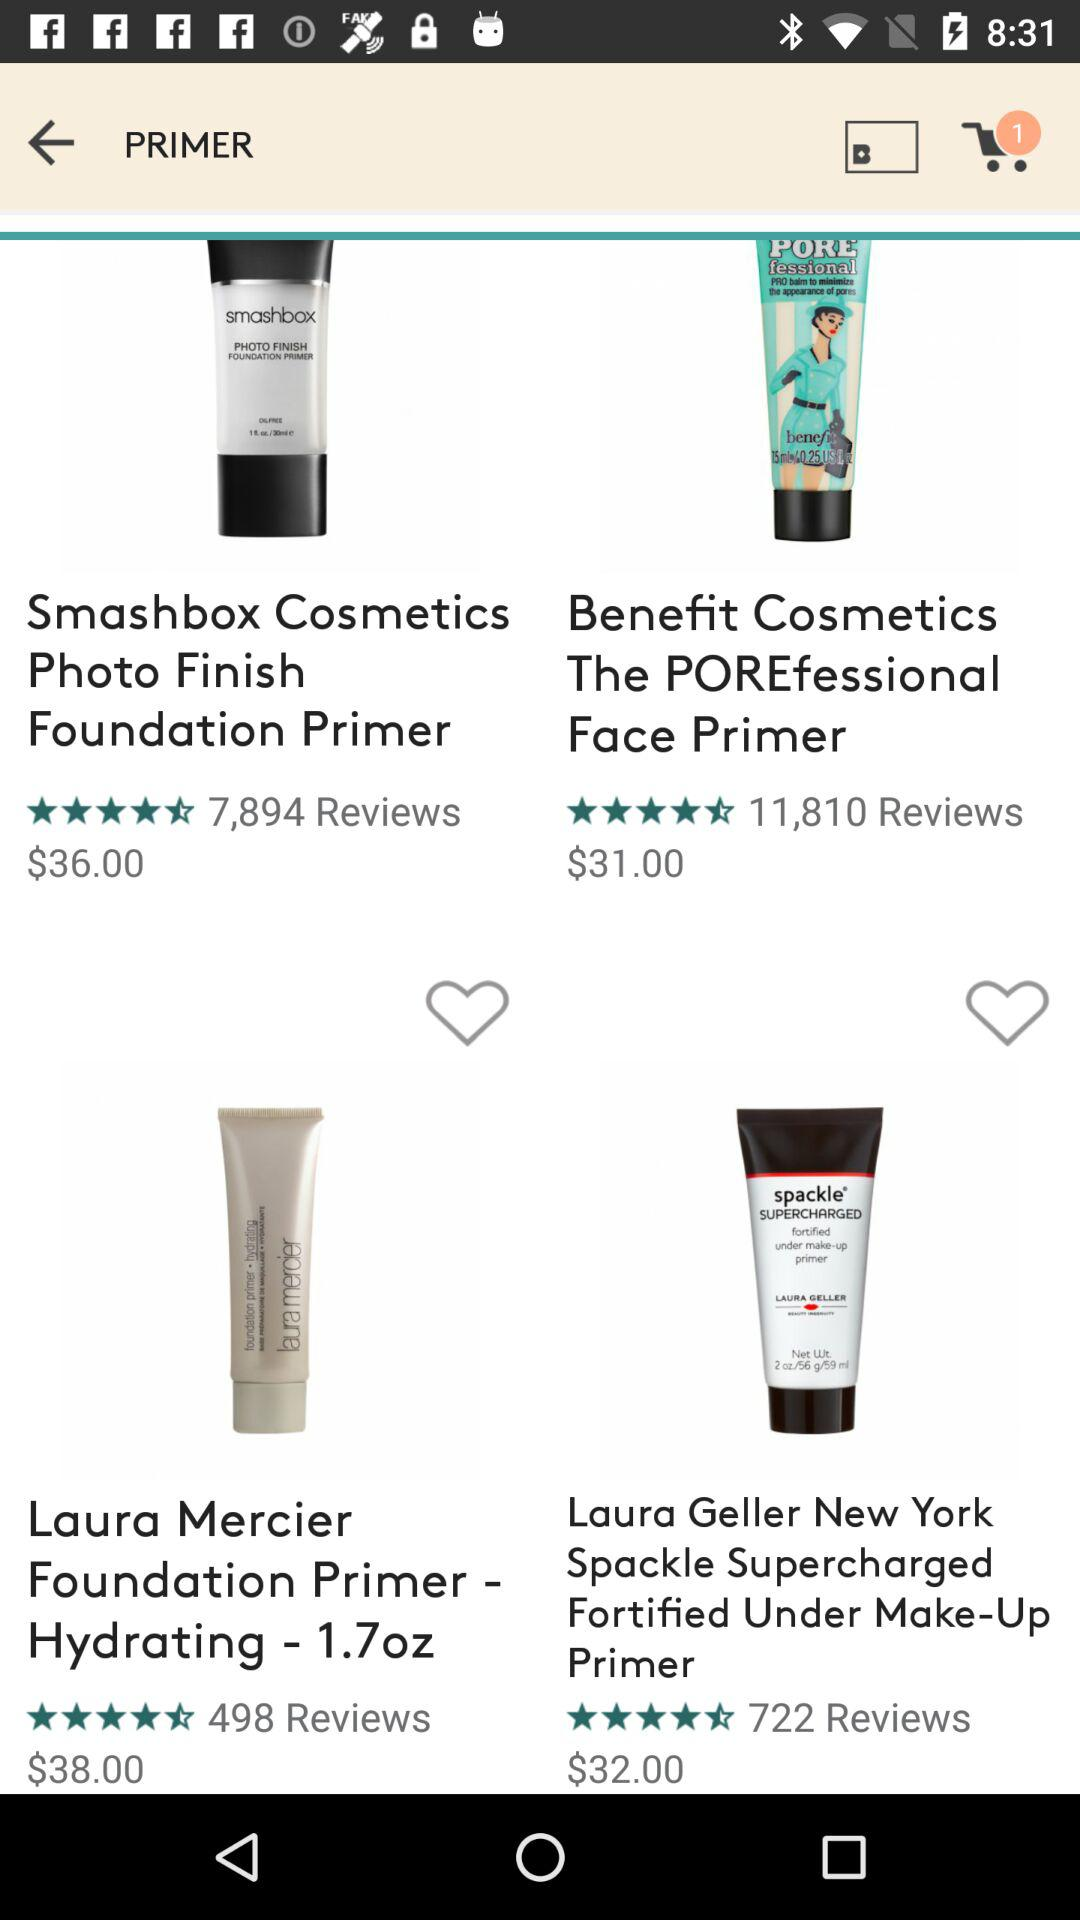What's the cost of "Laura Mercier Foundation Primer - Hydrating"? The cost is $38.00. 